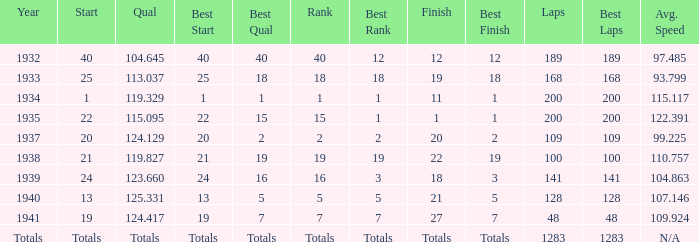What was the rank with the qual of 115.095? 15.0. 